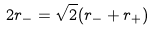<formula> <loc_0><loc_0><loc_500><loc_500>2 r _ { - } = \sqrt { 2 } ( r _ { - } + r _ { + } )</formula> 